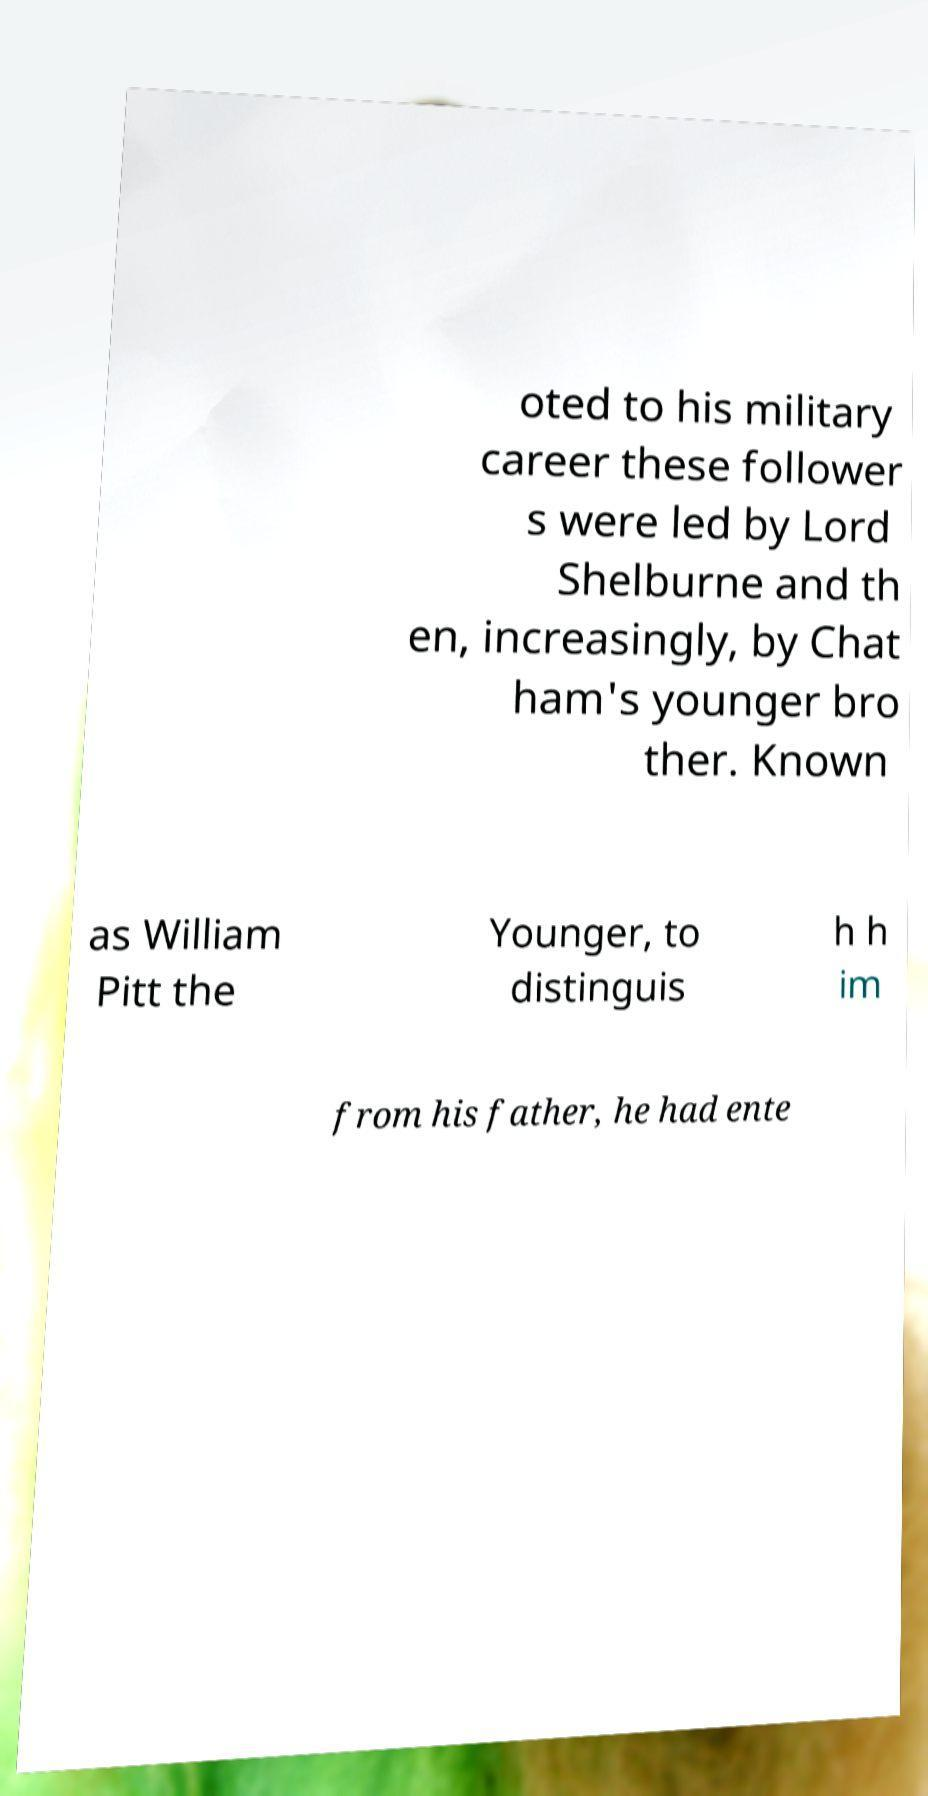Please identify and transcribe the text found in this image. oted to his military career these follower s were led by Lord Shelburne and th en, increasingly, by Chat ham's younger bro ther. Known as William Pitt the Younger, to distinguis h h im from his father, he had ente 